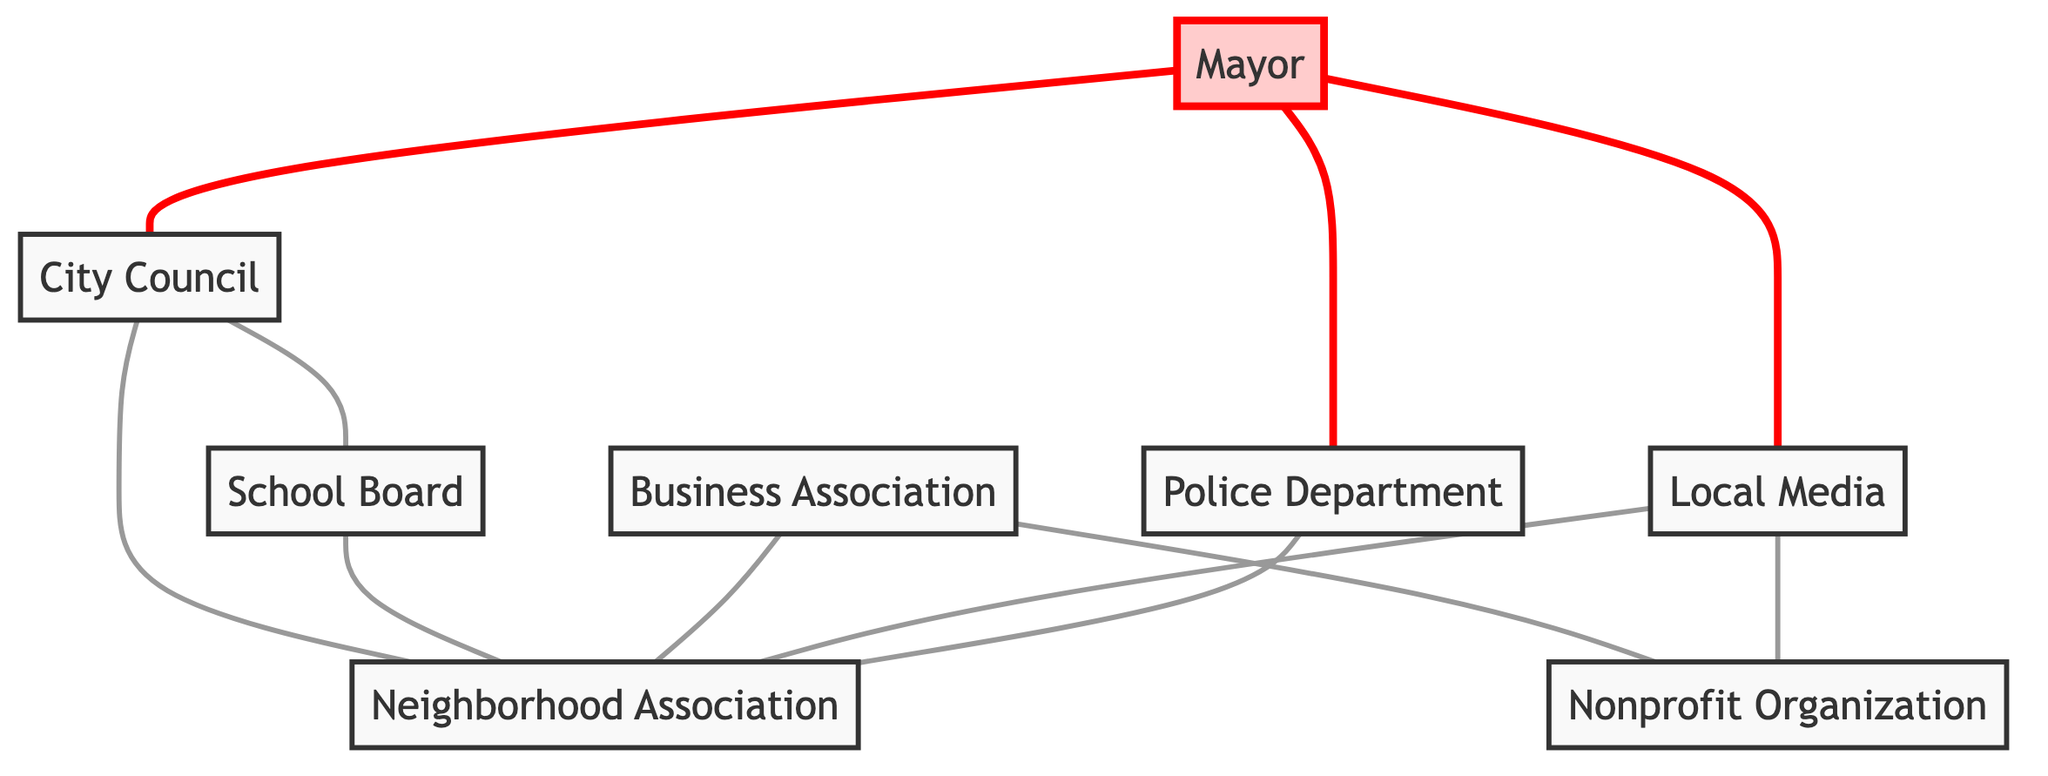What is the total number of nodes in the diagram? The nodes are the unique entities represented in the diagram, which include Mayor, City Council, School Board, Business Association, Neighborhood Association, Local Media, Police Department, and Nonprofit Organization. Counting these, we find there are 8 different nodes.
Answer: 8 How many connections (edges) does the Mayor have? The Mayor is connected to City Council, Local Media, and Police Department. Counting these edges gives us 3 connections.
Answer: 3 Which organization is connected to both the Business Association and the Local Media? The Neighborhood Association is connected to the Business Association and Local Media. It has direct edges linking it to both.
Answer: Neighborhood Association What is the relationship between City Council and School Board? The relationship is that there is an edge connecting the City Council to the School Board, indicating a direct connection or interaction between these two entities.
Answer: Connected Which entities are directly connected to the Neighborhood Association? The Neighborhood Association has edges connecting to City Council, School Board, Business Association, Local Media, and Police Department. Listing these gives us 5 entities.
Answer: 5 entities Is the Police Department connected to the Nonprofit Organization? There is no direct edge between Police Department and Nonprofit Organization in the diagram. Therefore, they are not directly connected.
Answer: No How many entities are connected to the City Council? The City Council is connected to School Board, Neighborhood Association, and Mayor, resulting in a total connection count of 3.
Answer: 3 Which nodes form the shortest path from the Mayor to the Nonprofit Organization? The route from Mayor ↔ City Council ↔ Neighborhood Association ↔ Nonprofit Organization forms a path. This constitutes a total of 3 edges.
Answer: 3 edges 